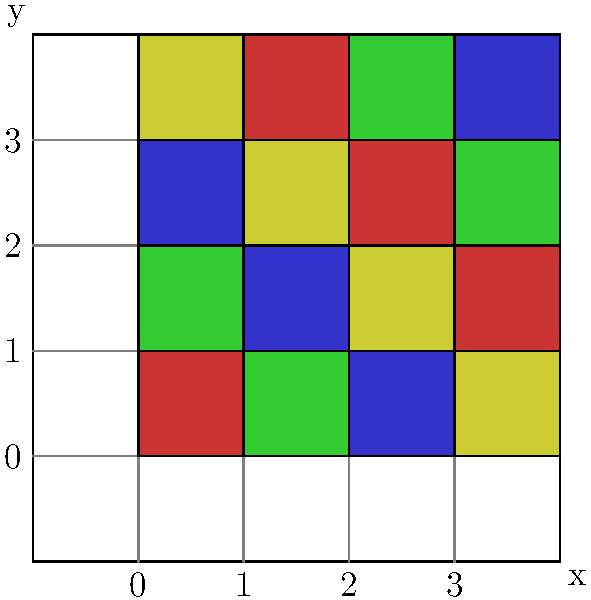In the given coordinate system, a color palette is mapped to specific coordinates for digital coloring in a comic book. The palette consists of four colors: red, green, blue, and yellow. The colors are assigned based on the sum of x and y coordinates, modulo 4. What color would be applied to the coordinate point (2, 3)? To determine the color at coordinate (2, 3), we need to follow these steps:

1. Identify the color mapping rule:
   - The color is determined by (x + y) mod 4
   - 0 = Red, 1 = Green, 2 = Blue, 3 = Yellow

2. Calculate the sum of the coordinates:
   x + y = 2 + 3 = 5

3. Apply the modulo operation:
   5 mod 4 = 1

4. Match the result to the color mapping:
   1 corresponds to Green

Therefore, the color applied to the coordinate point (2, 3) would be Green.
Answer: Green 